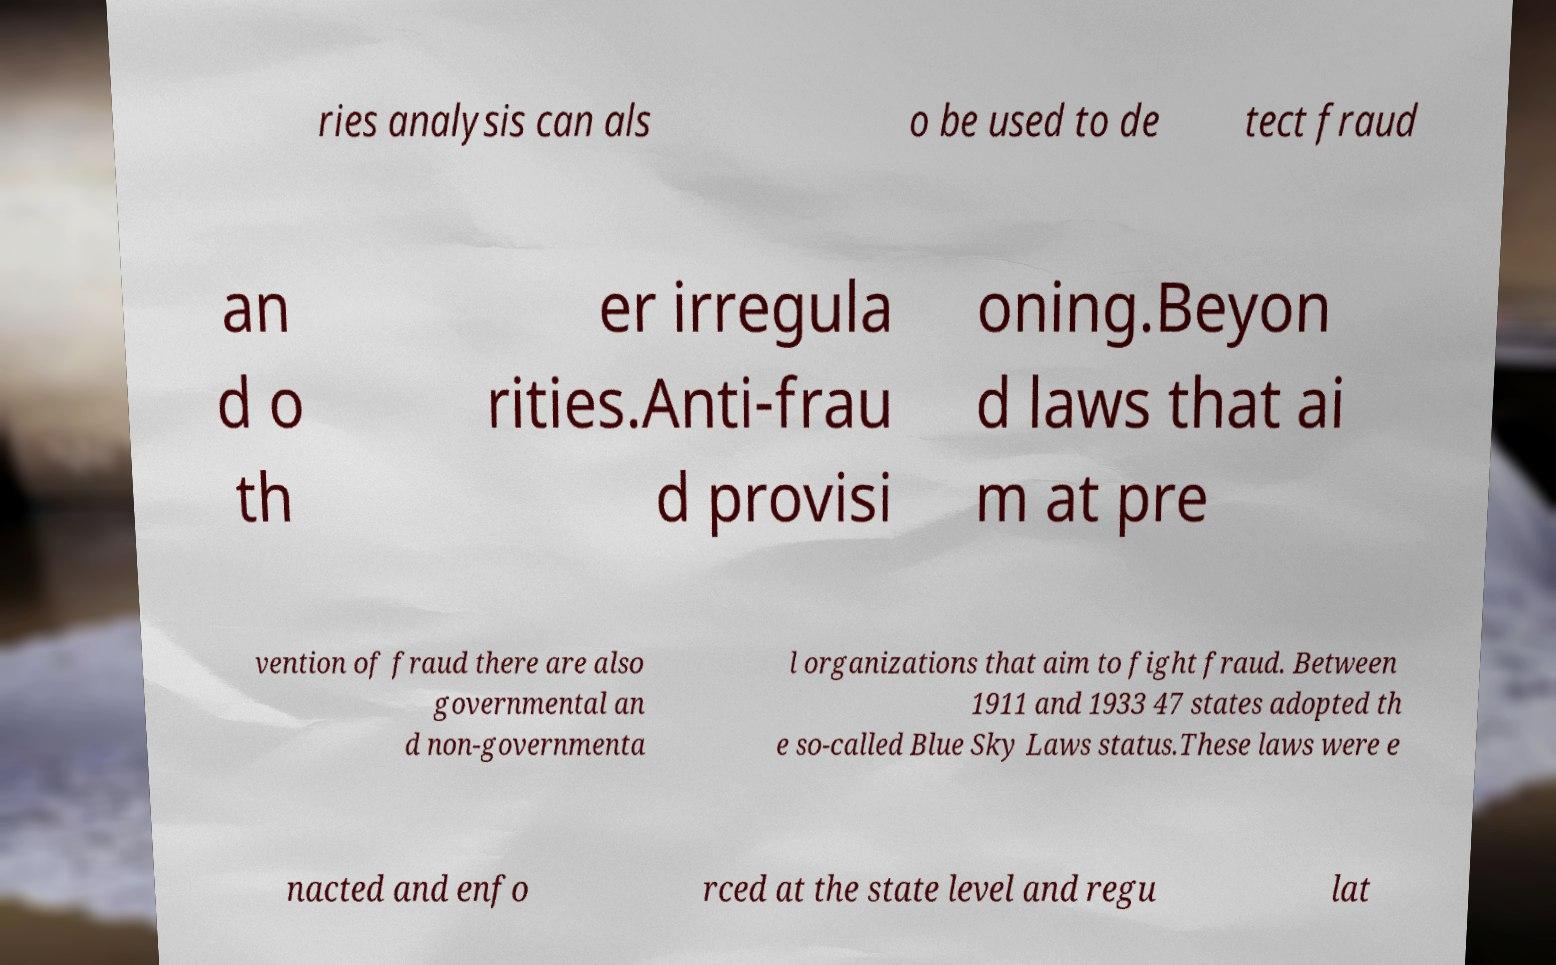There's text embedded in this image that I need extracted. Can you transcribe it verbatim? ries analysis can als o be used to de tect fraud an d o th er irregula rities.Anti-frau d provisi oning.Beyon d laws that ai m at pre vention of fraud there are also governmental an d non-governmenta l organizations that aim to fight fraud. Between 1911 and 1933 47 states adopted th e so-called Blue Sky Laws status.These laws were e nacted and enfo rced at the state level and regu lat 